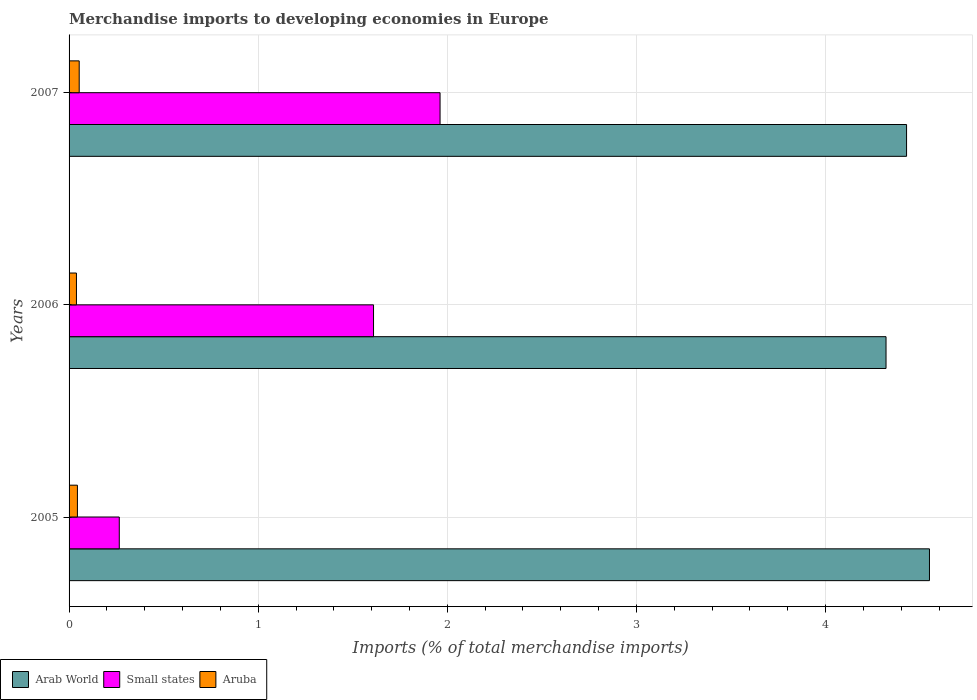How many different coloured bars are there?
Ensure brevity in your answer.  3. Are the number of bars per tick equal to the number of legend labels?
Offer a very short reply. Yes. How many bars are there on the 3rd tick from the top?
Ensure brevity in your answer.  3. How many bars are there on the 1st tick from the bottom?
Your answer should be very brief. 3. What is the label of the 3rd group of bars from the top?
Offer a terse response. 2005. In how many cases, is the number of bars for a given year not equal to the number of legend labels?
Give a very brief answer. 0. What is the percentage total merchandise imports in Aruba in 2007?
Offer a terse response. 0.05. Across all years, what is the maximum percentage total merchandise imports in Aruba?
Give a very brief answer. 0.05. Across all years, what is the minimum percentage total merchandise imports in Small states?
Make the answer very short. 0.27. In which year was the percentage total merchandise imports in Arab World maximum?
Keep it short and to the point. 2005. In which year was the percentage total merchandise imports in Small states minimum?
Offer a very short reply. 2005. What is the total percentage total merchandise imports in Arab World in the graph?
Keep it short and to the point. 13.3. What is the difference between the percentage total merchandise imports in Aruba in 2005 and that in 2006?
Make the answer very short. 0.01. What is the difference between the percentage total merchandise imports in Aruba in 2005 and the percentage total merchandise imports in Small states in 2007?
Your response must be concise. -1.92. What is the average percentage total merchandise imports in Aruba per year?
Keep it short and to the point. 0.05. In the year 2005, what is the difference between the percentage total merchandise imports in Arab World and percentage total merchandise imports in Small states?
Offer a terse response. 4.28. In how many years, is the percentage total merchandise imports in Small states greater than 0.8 %?
Make the answer very short. 2. What is the ratio of the percentage total merchandise imports in Aruba in 2006 to that in 2007?
Offer a very short reply. 0.73. Is the percentage total merchandise imports in Small states in 2005 less than that in 2006?
Keep it short and to the point. Yes. Is the difference between the percentage total merchandise imports in Arab World in 2006 and 2007 greater than the difference between the percentage total merchandise imports in Small states in 2006 and 2007?
Offer a very short reply. Yes. What is the difference between the highest and the second highest percentage total merchandise imports in Small states?
Offer a very short reply. 0.35. What is the difference between the highest and the lowest percentage total merchandise imports in Aruba?
Offer a terse response. 0.01. Is the sum of the percentage total merchandise imports in Arab World in 2005 and 2007 greater than the maximum percentage total merchandise imports in Aruba across all years?
Make the answer very short. Yes. What does the 2nd bar from the top in 2005 represents?
Provide a succinct answer. Small states. What does the 3rd bar from the bottom in 2005 represents?
Your response must be concise. Aruba. Are the values on the major ticks of X-axis written in scientific E-notation?
Offer a terse response. No. Does the graph contain any zero values?
Your response must be concise. No. Does the graph contain grids?
Offer a very short reply. Yes. Where does the legend appear in the graph?
Ensure brevity in your answer.  Bottom left. How many legend labels are there?
Provide a succinct answer. 3. What is the title of the graph?
Provide a succinct answer. Merchandise imports to developing economies in Europe. What is the label or title of the X-axis?
Your answer should be very brief. Imports (% of total merchandise imports). What is the Imports (% of total merchandise imports) in Arab World in 2005?
Keep it short and to the point. 4.55. What is the Imports (% of total merchandise imports) of Small states in 2005?
Offer a terse response. 0.27. What is the Imports (% of total merchandise imports) of Aruba in 2005?
Provide a succinct answer. 0.04. What is the Imports (% of total merchandise imports) of Arab World in 2006?
Provide a short and direct response. 4.32. What is the Imports (% of total merchandise imports) in Small states in 2006?
Offer a terse response. 1.61. What is the Imports (% of total merchandise imports) of Aruba in 2006?
Provide a short and direct response. 0.04. What is the Imports (% of total merchandise imports) in Arab World in 2007?
Offer a terse response. 4.43. What is the Imports (% of total merchandise imports) of Small states in 2007?
Your response must be concise. 1.96. What is the Imports (% of total merchandise imports) in Aruba in 2007?
Provide a short and direct response. 0.05. Across all years, what is the maximum Imports (% of total merchandise imports) of Arab World?
Provide a succinct answer. 4.55. Across all years, what is the maximum Imports (% of total merchandise imports) in Small states?
Give a very brief answer. 1.96. Across all years, what is the maximum Imports (% of total merchandise imports) in Aruba?
Ensure brevity in your answer.  0.05. Across all years, what is the minimum Imports (% of total merchandise imports) of Arab World?
Keep it short and to the point. 4.32. Across all years, what is the minimum Imports (% of total merchandise imports) in Small states?
Offer a very short reply. 0.27. Across all years, what is the minimum Imports (% of total merchandise imports) in Aruba?
Ensure brevity in your answer.  0.04. What is the total Imports (% of total merchandise imports) in Arab World in the graph?
Give a very brief answer. 13.3. What is the total Imports (% of total merchandise imports) in Small states in the graph?
Provide a short and direct response. 3.84. What is the total Imports (% of total merchandise imports) of Aruba in the graph?
Keep it short and to the point. 0.14. What is the difference between the Imports (% of total merchandise imports) in Arab World in 2005 and that in 2006?
Your response must be concise. 0.23. What is the difference between the Imports (% of total merchandise imports) in Small states in 2005 and that in 2006?
Keep it short and to the point. -1.34. What is the difference between the Imports (% of total merchandise imports) in Aruba in 2005 and that in 2006?
Provide a succinct answer. 0.01. What is the difference between the Imports (% of total merchandise imports) of Arab World in 2005 and that in 2007?
Offer a terse response. 0.12. What is the difference between the Imports (% of total merchandise imports) of Small states in 2005 and that in 2007?
Your answer should be compact. -1.7. What is the difference between the Imports (% of total merchandise imports) of Aruba in 2005 and that in 2007?
Your response must be concise. -0.01. What is the difference between the Imports (% of total merchandise imports) in Arab World in 2006 and that in 2007?
Make the answer very short. -0.11. What is the difference between the Imports (% of total merchandise imports) of Small states in 2006 and that in 2007?
Make the answer very short. -0.35. What is the difference between the Imports (% of total merchandise imports) of Aruba in 2006 and that in 2007?
Keep it short and to the point. -0.01. What is the difference between the Imports (% of total merchandise imports) of Arab World in 2005 and the Imports (% of total merchandise imports) of Small states in 2006?
Your response must be concise. 2.94. What is the difference between the Imports (% of total merchandise imports) in Arab World in 2005 and the Imports (% of total merchandise imports) in Aruba in 2006?
Ensure brevity in your answer.  4.51. What is the difference between the Imports (% of total merchandise imports) in Small states in 2005 and the Imports (% of total merchandise imports) in Aruba in 2006?
Keep it short and to the point. 0.23. What is the difference between the Imports (% of total merchandise imports) in Arab World in 2005 and the Imports (% of total merchandise imports) in Small states in 2007?
Ensure brevity in your answer.  2.59. What is the difference between the Imports (% of total merchandise imports) in Arab World in 2005 and the Imports (% of total merchandise imports) in Aruba in 2007?
Offer a very short reply. 4.5. What is the difference between the Imports (% of total merchandise imports) of Small states in 2005 and the Imports (% of total merchandise imports) of Aruba in 2007?
Your response must be concise. 0.21. What is the difference between the Imports (% of total merchandise imports) in Arab World in 2006 and the Imports (% of total merchandise imports) in Small states in 2007?
Your answer should be very brief. 2.36. What is the difference between the Imports (% of total merchandise imports) in Arab World in 2006 and the Imports (% of total merchandise imports) in Aruba in 2007?
Keep it short and to the point. 4.27. What is the difference between the Imports (% of total merchandise imports) of Small states in 2006 and the Imports (% of total merchandise imports) of Aruba in 2007?
Make the answer very short. 1.56. What is the average Imports (% of total merchandise imports) of Arab World per year?
Offer a very short reply. 4.43. What is the average Imports (% of total merchandise imports) of Small states per year?
Your answer should be very brief. 1.28. What is the average Imports (% of total merchandise imports) of Aruba per year?
Ensure brevity in your answer.  0.05. In the year 2005, what is the difference between the Imports (% of total merchandise imports) of Arab World and Imports (% of total merchandise imports) of Small states?
Offer a very short reply. 4.28. In the year 2005, what is the difference between the Imports (% of total merchandise imports) in Arab World and Imports (% of total merchandise imports) in Aruba?
Offer a very short reply. 4.51. In the year 2005, what is the difference between the Imports (% of total merchandise imports) of Small states and Imports (% of total merchandise imports) of Aruba?
Make the answer very short. 0.22. In the year 2006, what is the difference between the Imports (% of total merchandise imports) in Arab World and Imports (% of total merchandise imports) in Small states?
Provide a succinct answer. 2.71. In the year 2006, what is the difference between the Imports (% of total merchandise imports) in Arab World and Imports (% of total merchandise imports) in Aruba?
Offer a terse response. 4.28. In the year 2006, what is the difference between the Imports (% of total merchandise imports) of Small states and Imports (% of total merchandise imports) of Aruba?
Provide a short and direct response. 1.57. In the year 2007, what is the difference between the Imports (% of total merchandise imports) of Arab World and Imports (% of total merchandise imports) of Small states?
Ensure brevity in your answer.  2.47. In the year 2007, what is the difference between the Imports (% of total merchandise imports) of Arab World and Imports (% of total merchandise imports) of Aruba?
Provide a short and direct response. 4.37. In the year 2007, what is the difference between the Imports (% of total merchandise imports) in Small states and Imports (% of total merchandise imports) in Aruba?
Your response must be concise. 1.91. What is the ratio of the Imports (% of total merchandise imports) in Arab World in 2005 to that in 2006?
Make the answer very short. 1.05. What is the ratio of the Imports (% of total merchandise imports) of Small states in 2005 to that in 2006?
Offer a very short reply. 0.16. What is the ratio of the Imports (% of total merchandise imports) of Aruba in 2005 to that in 2006?
Your answer should be very brief. 1.13. What is the ratio of the Imports (% of total merchandise imports) of Arab World in 2005 to that in 2007?
Provide a short and direct response. 1.03. What is the ratio of the Imports (% of total merchandise imports) in Small states in 2005 to that in 2007?
Offer a very short reply. 0.14. What is the ratio of the Imports (% of total merchandise imports) in Aruba in 2005 to that in 2007?
Offer a terse response. 0.82. What is the ratio of the Imports (% of total merchandise imports) of Arab World in 2006 to that in 2007?
Give a very brief answer. 0.98. What is the ratio of the Imports (% of total merchandise imports) in Small states in 2006 to that in 2007?
Keep it short and to the point. 0.82. What is the ratio of the Imports (% of total merchandise imports) of Aruba in 2006 to that in 2007?
Make the answer very short. 0.73. What is the difference between the highest and the second highest Imports (% of total merchandise imports) of Arab World?
Provide a succinct answer. 0.12. What is the difference between the highest and the second highest Imports (% of total merchandise imports) of Small states?
Ensure brevity in your answer.  0.35. What is the difference between the highest and the second highest Imports (% of total merchandise imports) in Aruba?
Your answer should be very brief. 0.01. What is the difference between the highest and the lowest Imports (% of total merchandise imports) of Arab World?
Provide a succinct answer. 0.23. What is the difference between the highest and the lowest Imports (% of total merchandise imports) in Small states?
Your answer should be compact. 1.7. What is the difference between the highest and the lowest Imports (% of total merchandise imports) of Aruba?
Make the answer very short. 0.01. 